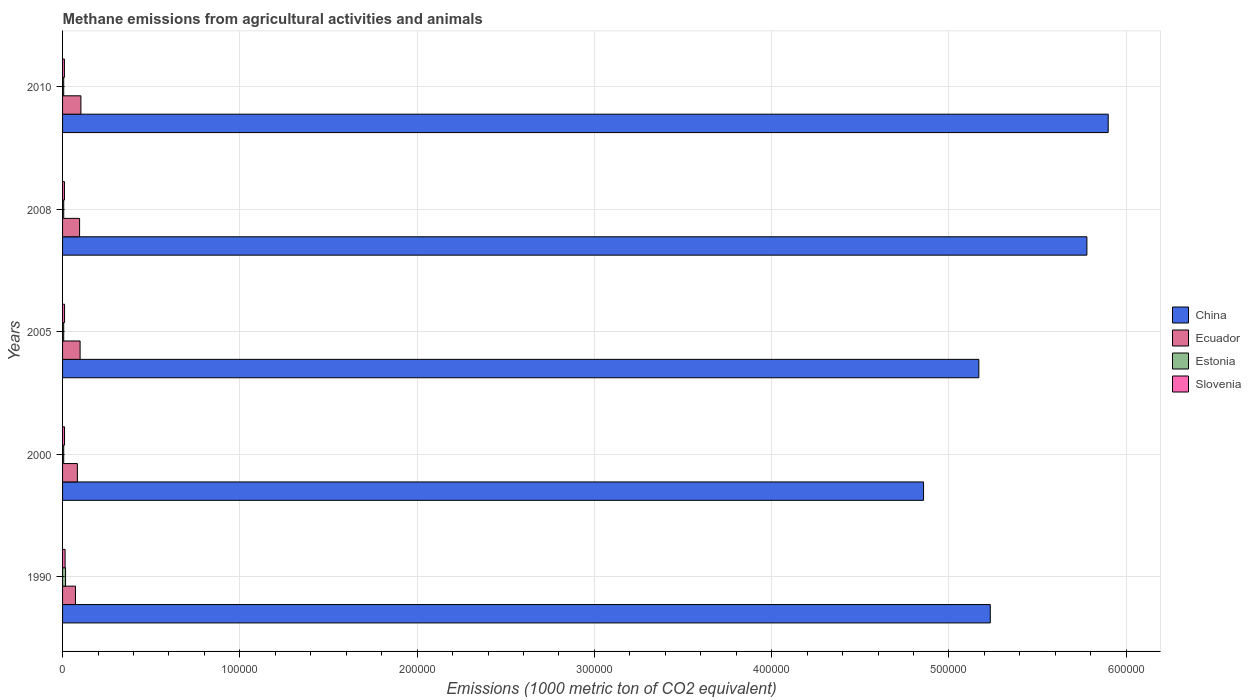How many groups of bars are there?
Offer a very short reply. 5. Are the number of bars on each tick of the Y-axis equal?
Your answer should be compact. Yes. How many bars are there on the 1st tick from the top?
Ensure brevity in your answer.  4. How many bars are there on the 3rd tick from the bottom?
Offer a terse response. 4. What is the label of the 2nd group of bars from the top?
Your response must be concise. 2008. What is the amount of methane emitted in Estonia in 1990?
Ensure brevity in your answer.  1685. Across all years, what is the maximum amount of methane emitted in Estonia?
Give a very brief answer. 1685. Across all years, what is the minimum amount of methane emitted in Ecuador?
Give a very brief answer. 7280. What is the total amount of methane emitted in Ecuador in the graph?
Your response must be concise. 4.55e+04. What is the difference between the amount of methane emitted in Ecuador in 1990 and that in 2008?
Offer a terse response. -2324.8. What is the difference between the amount of methane emitted in Slovenia in 2010 and the amount of methane emitted in Estonia in 2005?
Ensure brevity in your answer.  396.5. What is the average amount of methane emitted in Ecuador per year?
Your response must be concise. 9097.66. In the year 2000, what is the difference between the amount of methane emitted in Ecuador and amount of methane emitted in Estonia?
Offer a terse response. 7728.8. In how many years, is the amount of methane emitted in Estonia greater than 560000 1000 metric ton?
Your response must be concise. 0. What is the ratio of the amount of methane emitted in Ecuador in 2000 to that in 2005?
Make the answer very short. 0.85. Is the amount of methane emitted in Estonia in 2005 less than that in 2008?
Give a very brief answer. Yes. Is the difference between the amount of methane emitted in Ecuador in 1990 and 2008 greater than the difference between the amount of methane emitted in Estonia in 1990 and 2008?
Your response must be concise. No. What is the difference between the highest and the second highest amount of methane emitted in China?
Ensure brevity in your answer.  1.20e+04. What is the difference between the highest and the lowest amount of methane emitted in Estonia?
Ensure brevity in your answer.  1047.1. In how many years, is the amount of methane emitted in Ecuador greater than the average amount of methane emitted in Ecuador taken over all years?
Make the answer very short. 3. Is the sum of the amount of methane emitted in Estonia in 1990 and 2008 greater than the maximum amount of methane emitted in Ecuador across all years?
Provide a short and direct response. No. Is it the case that in every year, the sum of the amount of methane emitted in Ecuador and amount of methane emitted in Estonia is greater than the sum of amount of methane emitted in China and amount of methane emitted in Slovenia?
Your answer should be very brief. Yes. What does the 1st bar from the top in 2008 represents?
Provide a short and direct response. Slovenia. What does the 4th bar from the bottom in 2010 represents?
Make the answer very short. Slovenia. Is it the case that in every year, the sum of the amount of methane emitted in Slovenia and amount of methane emitted in China is greater than the amount of methane emitted in Ecuador?
Your answer should be compact. Yes. Are all the bars in the graph horizontal?
Provide a succinct answer. Yes. How many years are there in the graph?
Keep it short and to the point. 5. What is the difference between two consecutive major ticks on the X-axis?
Keep it short and to the point. 1.00e+05. Does the graph contain any zero values?
Your answer should be compact. No. Does the graph contain grids?
Offer a terse response. Yes. What is the title of the graph?
Your response must be concise. Methane emissions from agricultural activities and animals. What is the label or title of the X-axis?
Provide a short and direct response. Emissions (1000 metric ton of CO2 equivalent). What is the Emissions (1000 metric ton of CO2 equivalent) in China in 1990?
Your answer should be compact. 5.23e+05. What is the Emissions (1000 metric ton of CO2 equivalent) in Ecuador in 1990?
Give a very brief answer. 7280. What is the Emissions (1000 metric ton of CO2 equivalent) of Estonia in 1990?
Offer a very short reply. 1685. What is the Emissions (1000 metric ton of CO2 equivalent) of Slovenia in 1990?
Provide a short and direct response. 1413.5. What is the Emissions (1000 metric ton of CO2 equivalent) in China in 2000?
Offer a very short reply. 4.86e+05. What is the Emissions (1000 metric ton of CO2 equivalent) in Ecuador in 2000?
Give a very brief answer. 8366.7. What is the Emissions (1000 metric ton of CO2 equivalent) of Estonia in 2000?
Your response must be concise. 637.9. What is the Emissions (1000 metric ton of CO2 equivalent) of Slovenia in 2000?
Offer a very short reply. 1111. What is the Emissions (1000 metric ton of CO2 equivalent) in China in 2005?
Make the answer very short. 5.17e+05. What is the Emissions (1000 metric ton of CO2 equivalent) of Ecuador in 2005?
Make the answer very short. 9891. What is the Emissions (1000 metric ton of CO2 equivalent) of Estonia in 2005?
Your answer should be compact. 642.9. What is the Emissions (1000 metric ton of CO2 equivalent) of Slovenia in 2005?
Make the answer very short. 1124.6. What is the Emissions (1000 metric ton of CO2 equivalent) of China in 2008?
Offer a terse response. 5.78e+05. What is the Emissions (1000 metric ton of CO2 equivalent) of Ecuador in 2008?
Ensure brevity in your answer.  9604.8. What is the Emissions (1000 metric ton of CO2 equivalent) of Estonia in 2008?
Give a very brief answer. 654. What is the Emissions (1000 metric ton of CO2 equivalent) of Slovenia in 2008?
Your response must be concise. 1061.8. What is the Emissions (1000 metric ton of CO2 equivalent) of China in 2010?
Your answer should be compact. 5.90e+05. What is the Emissions (1000 metric ton of CO2 equivalent) in Ecuador in 2010?
Offer a terse response. 1.03e+04. What is the Emissions (1000 metric ton of CO2 equivalent) of Estonia in 2010?
Your answer should be very brief. 641.8. What is the Emissions (1000 metric ton of CO2 equivalent) of Slovenia in 2010?
Offer a very short reply. 1039.4. Across all years, what is the maximum Emissions (1000 metric ton of CO2 equivalent) in China?
Offer a terse response. 5.90e+05. Across all years, what is the maximum Emissions (1000 metric ton of CO2 equivalent) in Ecuador?
Your answer should be very brief. 1.03e+04. Across all years, what is the maximum Emissions (1000 metric ton of CO2 equivalent) of Estonia?
Offer a very short reply. 1685. Across all years, what is the maximum Emissions (1000 metric ton of CO2 equivalent) of Slovenia?
Make the answer very short. 1413.5. Across all years, what is the minimum Emissions (1000 metric ton of CO2 equivalent) in China?
Provide a succinct answer. 4.86e+05. Across all years, what is the minimum Emissions (1000 metric ton of CO2 equivalent) of Ecuador?
Make the answer very short. 7280. Across all years, what is the minimum Emissions (1000 metric ton of CO2 equivalent) of Estonia?
Give a very brief answer. 637.9. Across all years, what is the minimum Emissions (1000 metric ton of CO2 equivalent) in Slovenia?
Your answer should be compact. 1039.4. What is the total Emissions (1000 metric ton of CO2 equivalent) of China in the graph?
Ensure brevity in your answer.  2.69e+06. What is the total Emissions (1000 metric ton of CO2 equivalent) of Ecuador in the graph?
Make the answer very short. 4.55e+04. What is the total Emissions (1000 metric ton of CO2 equivalent) in Estonia in the graph?
Offer a terse response. 4261.6. What is the total Emissions (1000 metric ton of CO2 equivalent) of Slovenia in the graph?
Keep it short and to the point. 5750.3. What is the difference between the Emissions (1000 metric ton of CO2 equivalent) in China in 1990 and that in 2000?
Give a very brief answer. 3.76e+04. What is the difference between the Emissions (1000 metric ton of CO2 equivalent) in Ecuador in 1990 and that in 2000?
Give a very brief answer. -1086.7. What is the difference between the Emissions (1000 metric ton of CO2 equivalent) of Estonia in 1990 and that in 2000?
Keep it short and to the point. 1047.1. What is the difference between the Emissions (1000 metric ton of CO2 equivalent) of Slovenia in 1990 and that in 2000?
Offer a very short reply. 302.5. What is the difference between the Emissions (1000 metric ton of CO2 equivalent) of China in 1990 and that in 2005?
Your answer should be very brief. 6449.7. What is the difference between the Emissions (1000 metric ton of CO2 equivalent) in Ecuador in 1990 and that in 2005?
Offer a terse response. -2611. What is the difference between the Emissions (1000 metric ton of CO2 equivalent) in Estonia in 1990 and that in 2005?
Your answer should be compact. 1042.1. What is the difference between the Emissions (1000 metric ton of CO2 equivalent) of Slovenia in 1990 and that in 2005?
Give a very brief answer. 288.9. What is the difference between the Emissions (1000 metric ton of CO2 equivalent) in China in 1990 and that in 2008?
Give a very brief answer. -5.45e+04. What is the difference between the Emissions (1000 metric ton of CO2 equivalent) of Ecuador in 1990 and that in 2008?
Your answer should be very brief. -2324.8. What is the difference between the Emissions (1000 metric ton of CO2 equivalent) in Estonia in 1990 and that in 2008?
Your answer should be compact. 1031. What is the difference between the Emissions (1000 metric ton of CO2 equivalent) of Slovenia in 1990 and that in 2008?
Offer a very short reply. 351.7. What is the difference between the Emissions (1000 metric ton of CO2 equivalent) of China in 1990 and that in 2010?
Ensure brevity in your answer.  -6.65e+04. What is the difference between the Emissions (1000 metric ton of CO2 equivalent) in Ecuador in 1990 and that in 2010?
Keep it short and to the point. -3065.8. What is the difference between the Emissions (1000 metric ton of CO2 equivalent) of Estonia in 1990 and that in 2010?
Offer a very short reply. 1043.2. What is the difference between the Emissions (1000 metric ton of CO2 equivalent) of Slovenia in 1990 and that in 2010?
Provide a succinct answer. 374.1. What is the difference between the Emissions (1000 metric ton of CO2 equivalent) of China in 2000 and that in 2005?
Ensure brevity in your answer.  -3.12e+04. What is the difference between the Emissions (1000 metric ton of CO2 equivalent) of Ecuador in 2000 and that in 2005?
Give a very brief answer. -1524.3. What is the difference between the Emissions (1000 metric ton of CO2 equivalent) of China in 2000 and that in 2008?
Ensure brevity in your answer.  -9.21e+04. What is the difference between the Emissions (1000 metric ton of CO2 equivalent) of Ecuador in 2000 and that in 2008?
Your response must be concise. -1238.1. What is the difference between the Emissions (1000 metric ton of CO2 equivalent) in Estonia in 2000 and that in 2008?
Offer a terse response. -16.1. What is the difference between the Emissions (1000 metric ton of CO2 equivalent) in Slovenia in 2000 and that in 2008?
Your response must be concise. 49.2. What is the difference between the Emissions (1000 metric ton of CO2 equivalent) in China in 2000 and that in 2010?
Your answer should be very brief. -1.04e+05. What is the difference between the Emissions (1000 metric ton of CO2 equivalent) in Ecuador in 2000 and that in 2010?
Ensure brevity in your answer.  -1979.1. What is the difference between the Emissions (1000 metric ton of CO2 equivalent) of Slovenia in 2000 and that in 2010?
Ensure brevity in your answer.  71.6. What is the difference between the Emissions (1000 metric ton of CO2 equivalent) in China in 2005 and that in 2008?
Offer a very short reply. -6.10e+04. What is the difference between the Emissions (1000 metric ton of CO2 equivalent) of Ecuador in 2005 and that in 2008?
Provide a succinct answer. 286.2. What is the difference between the Emissions (1000 metric ton of CO2 equivalent) in Slovenia in 2005 and that in 2008?
Give a very brief answer. 62.8. What is the difference between the Emissions (1000 metric ton of CO2 equivalent) of China in 2005 and that in 2010?
Ensure brevity in your answer.  -7.30e+04. What is the difference between the Emissions (1000 metric ton of CO2 equivalent) in Ecuador in 2005 and that in 2010?
Make the answer very short. -454.8. What is the difference between the Emissions (1000 metric ton of CO2 equivalent) in Estonia in 2005 and that in 2010?
Offer a terse response. 1.1. What is the difference between the Emissions (1000 metric ton of CO2 equivalent) in Slovenia in 2005 and that in 2010?
Give a very brief answer. 85.2. What is the difference between the Emissions (1000 metric ton of CO2 equivalent) in China in 2008 and that in 2010?
Keep it short and to the point. -1.20e+04. What is the difference between the Emissions (1000 metric ton of CO2 equivalent) in Ecuador in 2008 and that in 2010?
Make the answer very short. -741. What is the difference between the Emissions (1000 metric ton of CO2 equivalent) of Slovenia in 2008 and that in 2010?
Make the answer very short. 22.4. What is the difference between the Emissions (1000 metric ton of CO2 equivalent) in China in 1990 and the Emissions (1000 metric ton of CO2 equivalent) in Ecuador in 2000?
Provide a succinct answer. 5.15e+05. What is the difference between the Emissions (1000 metric ton of CO2 equivalent) in China in 1990 and the Emissions (1000 metric ton of CO2 equivalent) in Estonia in 2000?
Provide a succinct answer. 5.23e+05. What is the difference between the Emissions (1000 metric ton of CO2 equivalent) in China in 1990 and the Emissions (1000 metric ton of CO2 equivalent) in Slovenia in 2000?
Provide a short and direct response. 5.22e+05. What is the difference between the Emissions (1000 metric ton of CO2 equivalent) in Ecuador in 1990 and the Emissions (1000 metric ton of CO2 equivalent) in Estonia in 2000?
Provide a short and direct response. 6642.1. What is the difference between the Emissions (1000 metric ton of CO2 equivalent) in Ecuador in 1990 and the Emissions (1000 metric ton of CO2 equivalent) in Slovenia in 2000?
Ensure brevity in your answer.  6169. What is the difference between the Emissions (1000 metric ton of CO2 equivalent) in Estonia in 1990 and the Emissions (1000 metric ton of CO2 equivalent) in Slovenia in 2000?
Your response must be concise. 574. What is the difference between the Emissions (1000 metric ton of CO2 equivalent) in China in 1990 and the Emissions (1000 metric ton of CO2 equivalent) in Ecuador in 2005?
Offer a terse response. 5.13e+05. What is the difference between the Emissions (1000 metric ton of CO2 equivalent) in China in 1990 and the Emissions (1000 metric ton of CO2 equivalent) in Estonia in 2005?
Provide a short and direct response. 5.23e+05. What is the difference between the Emissions (1000 metric ton of CO2 equivalent) in China in 1990 and the Emissions (1000 metric ton of CO2 equivalent) in Slovenia in 2005?
Your response must be concise. 5.22e+05. What is the difference between the Emissions (1000 metric ton of CO2 equivalent) of Ecuador in 1990 and the Emissions (1000 metric ton of CO2 equivalent) of Estonia in 2005?
Give a very brief answer. 6637.1. What is the difference between the Emissions (1000 metric ton of CO2 equivalent) of Ecuador in 1990 and the Emissions (1000 metric ton of CO2 equivalent) of Slovenia in 2005?
Keep it short and to the point. 6155.4. What is the difference between the Emissions (1000 metric ton of CO2 equivalent) in Estonia in 1990 and the Emissions (1000 metric ton of CO2 equivalent) in Slovenia in 2005?
Ensure brevity in your answer.  560.4. What is the difference between the Emissions (1000 metric ton of CO2 equivalent) of China in 1990 and the Emissions (1000 metric ton of CO2 equivalent) of Ecuador in 2008?
Your response must be concise. 5.14e+05. What is the difference between the Emissions (1000 metric ton of CO2 equivalent) of China in 1990 and the Emissions (1000 metric ton of CO2 equivalent) of Estonia in 2008?
Offer a terse response. 5.23e+05. What is the difference between the Emissions (1000 metric ton of CO2 equivalent) in China in 1990 and the Emissions (1000 metric ton of CO2 equivalent) in Slovenia in 2008?
Your response must be concise. 5.22e+05. What is the difference between the Emissions (1000 metric ton of CO2 equivalent) in Ecuador in 1990 and the Emissions (1000 metric ton of CO2 equivalent) in Estonia in 2008?
Offer a very short reply. 6626. What is the difference between the Emissions (1000 metric ton of CO2 equivalent) in Ecuador in 1990 and the Emissions (1000 metric ton of CO2 equivalent) in Slovenia in 2008?
Provide a succinct answer. 6218.2. What is the difference between the Emissions (1000 metric ton of CO2 equivalent) of Estonia in 1990 and the Emissions (1000 metric ton of CO2 equivalent) of Slovenia in 2008?
Ensure brevity in your answer.  623.2. What is the difference between the Emissions (1000 metric ton of CO2 equivalent) of China in 1990 and the Emissions (1000 metric ton of CO2 equivalent) of Ecuador in 2010?
Your answer should be compact. 5.13e+05. What is the difference between the Emissions (1000 metric ton of CO2 equivalent) of China in 1990 and the Emissions (1000 metric ton of CO2 equivalent) of Estonia in 2010?
Your response must be concise. 5.23e+05. What is the difference between the Emissions (1000 metric ton of CO2 equivalent) in China in 1990 and the Emissions (1000 metric ton of CO2 equivalent) in Slovenia in 2010?
Give a very brief answer. 5.22e+05. What is the difference between the Emissions (1000 metric ton of CO2 equivalent) in Ecuador in 1990 and the Emissions (1000 metric ton of CO2 equivalent) in Estonia in 2010?
Your response must be concise. 6638.2. What is the difference between the Emissions (1000 metric ton of CO2 equivalent) of Ecuador in 1990 and the Emissions (1000 metric ton of CO2 equivalent) of Slovenia in 2010?
Offer a terse response. 6240.6. What is the difference between the Emissions (1000 metric ton of CO2 equivalent) of Estonia in 1990 and the Emissions (1000 metric ton of CO2 equivalent) of Slovenia in 2010?
Provide a succinct answer. 645.6. What is the difference between the Emissions (1000 metric ton of CO2 equivalent) of China in 2000 and the Emissions (1000 metric ton of CO2 equivalent) of Ecuador in 2005?
Offer a very short reply. 4.76e+05. What is the difference between the Emissions (1000 metric ton of CO2 equivalent) of China in 2000 and the Emissions (1000 metric ton of CO2 equivalent) of Estonia in 2005?
Make the answer very short. 4.85e+05. What is the difference between the Emissions (1000 metric ton of CO2 equivalent) in China in 2000 and the Emissions (1000 metric ton of CO2 equivalent) in Slovenia in 2005?
Provide a succinct answer. 4.85e+05. What is the difference between the Emissions (1000 metric ton of CO2 equivalent) in Ecuador in 2000 and the Emissions (1000 metric ton of CO2 equivalent) in Estonia in 2005?
Your response must be concise. 7723.8. What is the difference between the Emissions (1000 metric ton of CO2 equivalent) in Ecuador in 2000 and the Emissions (1000 metric ton of CO2 equivalent) in Slovenia in 2005?
Your answer should be very brief. 7242.1. What is the difference between the Emissions (1000 metric ton of CO2 equivalent) of Estonia in 2000 and the Emissions (1000 metric ton of CO2 equivalent) of Slovenia in 2005?
Ensure brevity in your answer.  -486.7. What is the difference between the Emissions (1000 metric ton of CO2 equivalent) of China in 2000 and the Emissions (1000 metric ton of CO2 equivalent) of Ecuador in 2008?
Your answer should be compact. 4.76e+05. What is the difference between the Emissions (1000 metric ton of CO2 equivalent) in China in 2000 and the Emissions (1000 metric ton of CO2 equivalent) in Estonia in 2008?
Your answer should be compact. 4.85e+05. What is the difference between the Emissions (1000 metric ton of CO2 equivalent) in China in 2000 and the Emissions (1000 metric ton of CO2 equivalent) in Slovenia in 2008?
Offer a terse response. 4.85e+05. What is the difference between the Emissions (1000 metric ton of CO2 equivalent) in Ecuador in 2000 and the Emissions (1000 metric ton of CO2 equivalent) in Estonia in 2008?
Ensure brevity in your answer.  7712.7. What is the difference between the Emissions (1000 metric ton of CO2 equivalent) in Ecuador in 2000 and the Emissions (1000 metric ton of CO2 equivalent) in Slovenia in 2008?
Give a very brief answer. 7304.9. What is the difference between the Emissions (1000 metric ton of CO2 equivalent) in Estonia in 2000 and the Emissions (1000 metric ton of CO2 equivalent) in Slovenia in 2008?
Provide a succinct answer. -423.9. What is the difference between the Emissions (1000 metric ton of CO2 equivalent) of China in 2000 and the Emissions (1000 metric ton of CO2 equivalent) of Ecuador in 2010?
Provide a short and direct response. 4.75e+05. What is the difference between the Emissions (1000 metric ton of CO2 equivalent) of China in 2000 and the Emissions (1000 metric ton of CO2 equivalent) of Estonia in 2010?
Make the answer very short. 4.85e+05. What is the difference between the Emissions (1000 metric ton of CO2 equivalent) in China in 2000 and the Emissions (1000 metric ton of CO2 equivalent) in Slovenia in 2010?
Your answer should be very brief. 4.85e+05. What is the difference between the Emissions (1000 metric ton of CO2 equivalent) of Ecuador in 2000 and the Emissions (1000 metric ton of CO2 equivalent) of Estonia in 2010?
Ensure brevity in your answer.  7724.9. What is the difference between the Emissions (1000 metric ton of CO2 equivalent) of Ecuador in 2000 and the Emissions (1000 metric ton of CO2 equivalent) of Slovenia in 2010?
Provide a short and direct response. 7327.3. What is the difference between the Emissions (1000 metric ton of CO2 equivalent) of Estonia in 2000 and the Emissions (1000 metric ton of CO2 equivalent) of Slovenia in 2010?
Your answer should be very brief. -401.5. What is the difference between the Emissions (1000 metric ton of CO2 equivalent) in China in 2005 and the Emissions (1000 metric ton of CO2 equivalent) in Ecuador in 2008?
Ensure brevity in your answer.  5.07e+05. What is the difference between the Emissions (1000 metric ton of CO2 equivalent) of China in 2005 and the Emissions (1000 metric ton of CO2 equivalent) of Estonia in 2008?
Offer a terse response. 5.16e+05. What is the difference between the Emissions (1000 metric ton of CO2 equivalent) of China in 2005 and the Emissions (1000 metric ton of CO2 equivalent) of Slovenia in 2008?
Provide a short and direct response. 5.16e+05. What is the difference between the Emissions (1000 metric ton of CO2 equivalent) in Ecuador in 2005 and the Emissions (1000 metric ton of CO2 equivalent) in Estonia in 2008?
Provide a succinct answer. 9237. What is the difference between the Emissions (1000 metric ton of CO2 equivalent) in Ecuador in 2005 and the Emissions (1000 metric ton of CO2 equivalent) in Slovenia in 2008?
Ensure brevity in your answer.  8829.2. What is the difference between the Emissions (1000 metric ton of CO2 equivalent) of Estonia in 2005 and the Emissions (1000 metric ton of CO2 equivalent) of Slovenia in 2008?
Ensure brevity in your answer.  -418.9. What is the difference between the Emissions (1000 metric ton of CO2 equivalent) in China in 2005 and the Emissions (1000 metric ton of CO2 equivalent) in Ecuador in 2010?
Offer a terse response. 5.07e+05. What is the difference between the Emissions (1000 metric ton of CO2 equivalent) of China in 2005 and the Emissions (1000 metric ton of CO2 equivalent) of Estonia in 2010?
Your response must be concise. 5.16e+05. What is the difference between the Emissions (1000 metric ton of CO2 equivalent) of China in 2005 and the Emissions (1000 metric ton of CO2 equivalent) of Slovenia in 2010?
Your answer should be very brief. 5.16e+05. What is the difference between the Emissions (1000 metric ton of CO2 equivalent) of Ecuador in 2005 and the Emissions (1000 metric ton of CO2 equivalent) of Estonia in 2010?
Give a very brief answer. 9249.2. What is the difference between the Emissions (1000 metric ton of CO2 equivalent) in Ecuador in 2005 and the Emissions (1000 metric ton of CO2 equivalent) in Slovenia in 2010?
Provide a short and direct response. 8851.6. What is the difference between the Emissions (1000 metric ton of CO2 equivalent) of Estonia in 2005 and the Emissions (1000 metric ton of CO2 equivalent) of Slovenia in 2010?
Your response must be concise. -396.5. What is the difference between the Emissions (1000 metric ton of CO2 equivalent) of China in 2008 and the Emissions (1000 metric ton of CO2 equivalent) of Ecuador in 2010?
Provide a short and direct response. 5.67e+05. What is the difference between the Emissions (1000 metric ton of CO2 equivalent) of China in 2008 and the Emissions (1000 metric ton of CO2 equivalent) of Estonia in 2010?
Your response must be concise. 5.77e+05. What is the difference between the Emissions (1000 metric ton of CO2 equivalent) of China in 2008 and the Emissions (1000 metric ton of CO2 equivalent) of Slovenia in 2010?
Offer a very short reply. 5.77e+05. What is the difference between the Emissions (1000 metric ton of CO2 equivalent) in Ecuador in 2008 and the Emissions (1000 metric ton of CO2 equivalent) in Estonia in 2010?
Ensure brevity in your answer.  8963. What is the difference between the Emissions (1000 metric ton of CO2 equivalent) in Ecuador in 2008 and the Emissions (1000 metric ton of CO2 equivalent) in Slovenia in 2010?
Your answer should be very brief. 8565.4. What is the difference between the Emissions (1000 metric ton of CO2 equivalent) in Estonia in 2008 and the Emissions (1000 metric ton of CO2 equivalent) in Slovenia in 2010?
Your answer should be very brief. -385.4. What is the average Emissions (1000 metric ton of CO2 equivalent) in China per year?
Your answer should be compact. 5.39e+05. What is the average Emissions (1000 metric ton of CO2 equivalent) of Ecuador per year?
Give a very brief answer. 9097.66. What is the average Emissions (1000 metric ton of CO2 equivalent) of Estonia per year?
Make the answer very short. 852.32. What is the average Emissions (1000 metric ton of CO2 equivalent) of Slovenia per year?
Offer a terse response. 1150.06. In the year 1990, what is the difference between the Emissions (1000 metric ton of CO2 equivalent) in China and Emissions (1000 metric ton of CO2 equivalent) in Ecuador?
Offer a very short reply. 5.16e+05. In the year 1990, what is the difference between the Emissions (1000 metric ton of CO2 equivalent) in China and Emissions (1000 metric ton of CO2 equivalent) in Estonia?
Provide a short and direct response. 5.22e+05. In the year 1990, what is the difference between the Emissions (1000 metric ton of CO2 equivalent) in China and Emissions (1000 metric ton of CO2 equivalent) in Slovenia?
Your response must be concise. 5.22e+05. In the year 1990, what is the difference between the Emissions (1000 metric ton of CO2 equivalent) of Ecuador and Emissions (1000 metric ton of CO2 equivalent) of Estonia?
Make the answer very short. 5595. In the year 1990, what is the difference between the Emissions (1000 metric ton of CO2 equivalent) in Ecuador and Emissions (1000 metric ton of CO2 equivalent) in Slovenia?
Ensure brevity in your answer.  5866.5. In the year 1990, what is the difference between the Emissions (1000 metric ton of CO2 equivalent) of Estonia and Emissions (1000 metric ton of CO2 equivalent) of Slovenia?
Offer a terse response. 271.5. In the year 2000, what is the difference between the Emissions (1000 metric ton of CO2 equivalent) in China and Emissions (1000 metric ton of CO2 equivalent) in Ecuador?
Your response must be concise. 4.77e+05. In the year 2000, what is the difference between the Emissions (1000 metric ton of CO2 equivalent) of China and Emissions (1000 metric ton of CO2 equivalent) of Estonia?
Your answer should be very brief. 4.85e+05. In the year 2000, what is the difference between the Emissions (1000 metric ton of CO2 equivalent) of China and Emissions (1000 metric ton of CO2 equivalent) of Slovenia?
Offer a very short reply. 4.85e+05. In the year 2000, what is the difference between the Emissions (1000 metric ton of CO2 equivalent) of Ecuador and Emissions (1000 metric ton of CO2 equivalent) of Estonia?
Offer a very short reply. 7728.8. In the year 2000, what is the difference between the Emissions (1000 metric ton of CO2 equivalent) of Ecuador and Emissions (1000 metric ton of CO2 equivalent) of Slovenia?
Your answer should be compact. 7255.7. In the year 2000, what is the difference between the Emissions (1000 metric ton of CO2 equivalent) in Estonia and Emissions (1000 metric ton of CO2 equivalent) in Slovenia?
Provide a short and direct response. -473.1. In the year 2005, what is the difference between the Emissions (1000 metric ton of CO2 equivalent) of China and Emissions (1000 metric ton of CO2 equivalent) of Ecuador?
Provide a short and direct response. 5.07e+05. In the year 2005, what is the difference between the Emissions (1000 metric ton of CO2 equivalent) of China and Emissions (1000 metric ton of CO2 equivalent) of Estonia?
Ensure brevity in your answer.  5.16e+05. In the year 2005, what is the difference between the Emissions (1000 metric ton of CO2 equivalent) of China and Emissions (1000 metric ton of CO2 equivalent) of Slovenia?
Give a very brief answer. 5.16e+05. In the year 2005, what is the difference between the Emissions (1000 metric ton of CO2 equivalent) of Ecuador and Emissions (1000 metric ton of CO2 equivalent) of Estonia?
Make the answer very short. 9248.1. In the year 2005, what is the difference between the Emissions (1000 metric ton of CO2 equivalent) of Ecuador and Emissions (1000 metric ton of CO2 equivalent) of Slovenia?
Offer a terse response. 8766.4. In the year 2005, what is the difference between the Emissions (1000 metric ton of CO2 equivalent) in Estonia and Emissions (1000 metric ton of CO2 equivalent) in Slovenia?
Keep it short and to the point. -481.7. In the year 2008, what is the difference between the Emissions (1000 metric ton of CO2 equivalent) of China and Emissions (1000 metric ton of CO2 equivalent) of Ecuador?
Your response must be concise. 5.68e+05. In the year 2008, what is the difference between the Emissions (1000 metric ton of CO2 equivalent) in China and Emissions (1000 metric ton of CO2 equivalent) in Estonia?
Offer a terse response. 5.77e+05. In the year 2008, what is the difference between the Emissions (1000 metric ton of CO2 equivalent) in China and Emissions (1000 metric ton of CO2 equivalent) in Slovenia?
Offer a terse response. 5.77e+05. In the year 2008, what is the difference between the Emissions (1000 metric ton of CO2 equivalent) of Ecuador and Emissions (1000 metric ton of CO2 equivalent) of Estonia?
Your response must be concise. 8950.8. In the year 2008, what is the difference between the Emissions (1000 metric ton of CO2 equivalent) of Ecuador and Emissions (1000 metric ton of CO2 equivalent) of Slovenia?
Provide a short and direct response. 8543. In the year 2008, what is the difference between the Emissions (1000 metric ton of CO2 equivalent) of Estonia and Emissions (1000 metric ton of CO2 equivalent) of Slovenia?
Provide a short and direct response. -407.8. In the year 2010, what is the difference between the Emissions (1000 metric ton of CO2 equivalent) of China and Emissions (1000 metric ton of CO2 equivalent) of Ecuador?
Your response must be concise. 5.80e+05. In the year 2010, what is the difference between the Emissions (1000 metric ton of CO2 equivalent) of China and Emissions (1000 metric ton of CO2 equivalent) of Estonia?
Give a very brief answer. 5.89e+05. In the year 2010, what is the difference between the Emissions (1000 metric ton of CO2 equivalent) of China and Emissions (1000 metric ton of CO2 equivalent) of Slovenia?
Offer a terse response. 5.89e+05. In the year 2010, what is the difference between the Emissions (1000 metric ton of CO2 equivalent) in Ecuador and Emissions (1000 metric ton of CO2 equivalent) in Estonia?
Your answer should be compact. 9704. In the year 2010, what is the difference between the Emissions (1000 metric ton of CO2 equivalent) of Ecuador and Emissions (1000 metric ton of CO2 equivalent) of Slovenia?
Your answer should be very brief. 9306.4. In the year 2010, what is the difference between the Emissions (1000 metric ton of CO2 equivalent) in Estonia and Emissions (1000 metric ton of CO2 equivalent) in Slovenia?
Your response must be concise. -397.6. What is the ratio of the Emissions (1000 metric ton of CO2 equivalent) of China in 1990 to that in 2000?
Offer a very short reply. 1.08. What is the ratio of the Emissions (1000 metric ton of CO2 equivalent) of Ecuador in 1990 to that in 2000?
Your answer should be very brief. 0.87. What is the ratio of the Emissions (1000 metric ton of CO2 equivalent) in Estonia in 1990 to that in 2000?
Your answer should be compact. 2.64. What is the ratio of the Emissions (1000 metric ton of CO2 equivalent) in Slovenia in 1990 to that in 2000?
Offer a very short reply. 1.27. What is the ratio of the Emissions (1000 metric ton of CO2 equivalent) in China in 1990 to that in 2005?
Your answer should be very brief. 1.01. What is the ratio of the Emissions (1000 metric ton of CO2 equivalent) of Ecuador in 1990 to that in 2005?
Ensure brevity in your answer.  0.74. What is the ratio of the Emissions (1000 metric ton of CO2 equivalent) of Estonia in 1990 to that in 2005?
Offer a terse response. 2.62. What is the ratio of the Emissions (1000 metric ton of CO2 equivalent) of Slovenia in 1990 to that in 2005?
Your answer should be very brief. 1.26. What is the ratio of the Emissions (1000 metric ton of CO2 equivalent) in China in 1990 to that in 2008?
Make the answer very short. 0.91. What is the ratio of the Emissions (1000 metric ton of CO2 equivalent) of Ecuador in 1990 to that in 2008?
Make the answer very short. 0.76. What is the ratio of the Emissions (1000 metric ton of CO2 equivalent) of Estonia in 1990 to that in 2008?
Offer a very short reply. 2.58. What is the ratio of the Emissions (1000 metric ton of CO2 equivalent) of Slovenia in 1990 to that in 2008?
Give a very brief answer. 1.33. What is the ratio of the Emissions (1000 metric ton of CO2 equivalent) of China in 1990 to that in 2010?
Give a very brief answer. 0.89. What is the ratio of the Emissions (1000 metric ton of CO2 equivalent) in Ecuador in 1990 to that in 2010?
Keep it short and to the point. 0.7. What is the ratio of the Emissions (1000 metric ton of CO2 equivalent) of Estonia in 1990 to that in 2010?
Offer a very short reply. 2.63. What is the ratio of the Emissions (1000 metric ton of CO2 equivalent) of Slovenia in 1990 to that in 2010?
Your answer should be very brief. 1.36. What is the ratio of the Emissions (1000 metric ton of CO2 equivalent) of China in 2000 to that in 2005?
Give a very brief answer. 0.94. What is the ratio of the Emissions (1000 metric ton of CO2 equivalent) in Ecuador in 2000 to that in 2005?
Give a very brief answer. 0.85. What is the ratio of the Emissions (1000 metric ton of CO2 equivalent) of Slovenia in 2000 to that in 2005?
Provide a short and direct response. 0.99. What is the ratio of the Emissions (1000 metric ton of CO2 equivalent) in China in 2000 to that in 2008?
Make the answer very short. 0.84. What is the ratio of the Emissions (1000 metric ton of CO2 equivalent) in Ecuador in 2000 to that in 2008?
Offer a very short reply. 0.87. What is the ratio of the Emissions (1000 metric ton of CO2 equivalent) of Estonia in 2000 to that in 2008?
Your answer should be compact. 0.98. What is the ratio of the Emissions (1000 metric ton of CO2 equivalent) in Slovenia in 2000 to that in 2008?
Keep it short and to the point. 1.05. What is the ratio of the Emissions (1000 metric ton of CO2 equivalent) of China in 2000 to that in 2010?
Offer a terse response. 0.82. What is the ratio of the Emissions (1000 metric ton of CO2 equivalent) in Ecuador in 2000 to that in 2010?
Offer a terse response. 0.81. What is the ratio of the Emissions (1000 metric ton of CO2 equivalent) of Slovenia in 2000 to that in 2010?
Provide a succinct answer. 1.07. What is the ratio of the Emissions (1000 metric ton of CO2 equivalent) in China in 2005 to that in 2008?
Make the answer very short. 0.89. What is the ratio of the Emissions (1000 metric ton of CO2 equivalent) of Ecuador in 2005 to that in 2008?
Your response must be concise. 1.03. What is the ratio of the Emissions (1000 metric ton of CO2 equivalent) of Slovenia in 2005 to that in 2008?
Your response must be concise. 1.06. What is the ratio of the Emissions (1000 metric ton of CO2 equivalent) in China in 2005 to that in 2010?
Make the answer very short. 0.88. What is the ratio of the Emissions (1000 metric ton of CO2 equivalent) in Ecuador in 2005 to that in 2010?
Ensure brevity in your answer.  0.96. What is the ratio of the Emissions (1000 metric ton of CO2 equivalent) of Slovenia in 2005 to that in 2010?
Keep it short and to the point. 1.08. What is the ratio of the Emissions (1000 metric ton of CO2 equivalent) in China in 2008 to that in 2010?
Ensure brevity in your answer.  0.98. What is the ratio of the Emissions (1000 metric ton of CO2 equivalent) in Ecuador in 2008 to that in 2010?
Keep it short and to the point. 0.93. What is the ratio of the Emissions (1000 metric ton of CO2 equivalent) of Estonia in 2008 to that in 2010?
Provide a succinct answer. 1.02. What is the ratio of the Emissions (1000 metric ton of CO2 equivalent) of Slovenia in 2008 to that in 2010?
Make the answer very short. 1.02. What is the difference between the highest and the second highest Emissions (1000 metric ton of CO2 equivalent) in China?
Keep it short and to the point. 1.20e+04. What is the difference between the highest and the second highest Emissions (1000 metric ton of CO2 equivalent) in Ecuador?
Keep it short and to the point. 454.8. What is the difference between the highest and the second highest Emissions (1000 metric ton of CO2 equivalent) in Estonia?
Keep it short and to the point. 1031. What is the difference between the highest and the second highest Emissions (1000 metric ton of CO2 equivalent) in Slovenia?
Provide a short and direct response. 288.9. What is the difference between the highest and the lowest Emissions (1000 metric ton of CO2 equivalent) in China?
Your response must be concise. 1.04e+05. What is the difference between the highest and the lowest Emissions (1000 metric ton of CO2 equivalent) in Ecuador?
Keep it short and to the point. 3065.8. What is the difference between the highest and the lowest Emissions (1000 metric ton of CO2 equivalent) in Estonia?
Provide a succinct answer. 1047.1. What is the difference between the highest and the lowest Emissions (1000 metric ton of CO2 equivalent) of Slovenia?
Your answer should be compact. 374.1. 